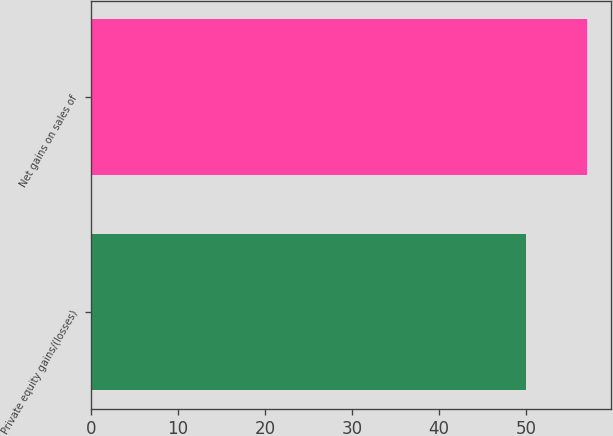<chart> <loc_0><loc_0><loc_500><loc_500><bar_chart><fcel>Private equity gains/(losses)<fcel>Net gains on sales of<nl><fcel>50<fcel>57<nl></chart> 